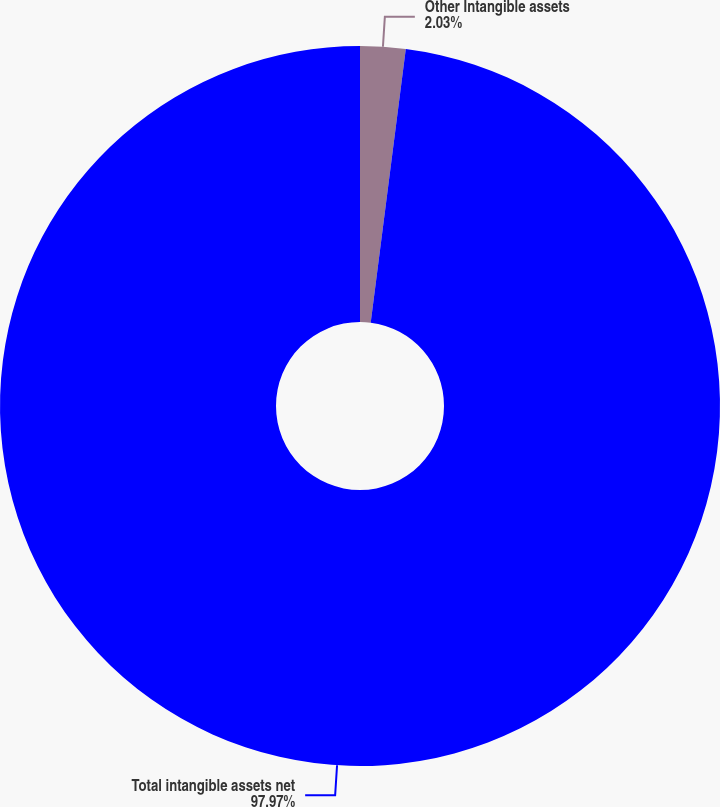<chart> <loc_0><loc_0><loc_500><loc_500><pie_chart><fcel>Other Intangible assets<fcel>Total intangible assets net<nl><fcel>2.03%<fcel>97.97%<nl></chart> 